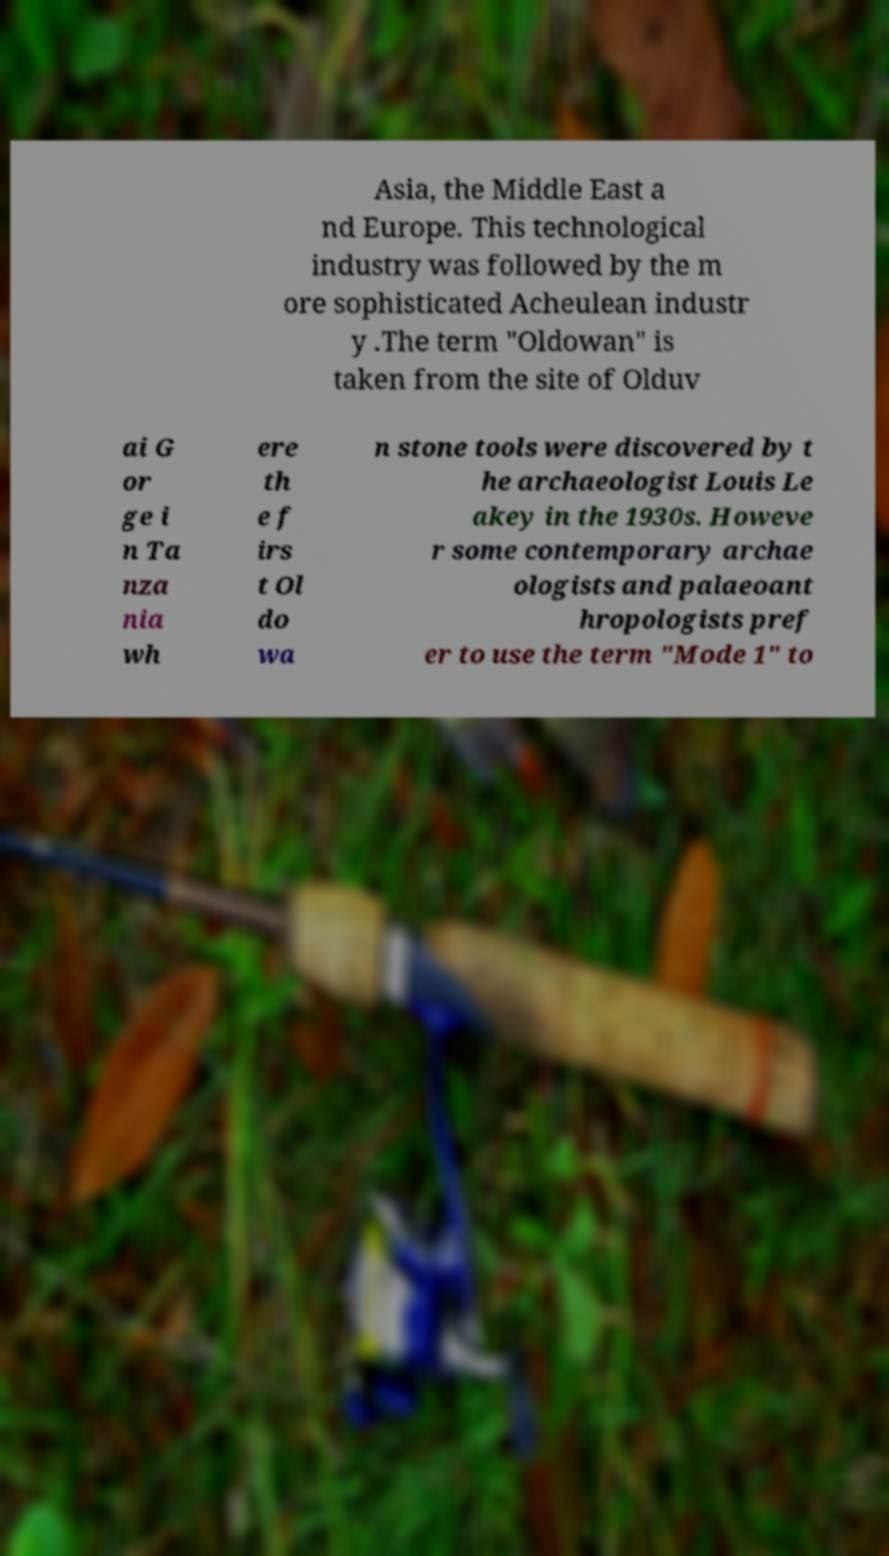Could you assist in decoding the text presented in this image and type it out clearly? Asia, the Middle East a nd Europe. This technological industry was followed by the m ore sophisticated Acheulean industr y .The term "Oldowan" is taken from the site of Olduv ai G or ge i n Ta nza nia wh ere th e f irs t Ol do wa n stone tools were discovered by t he archaeologist Louis Le akey in the 1930s. Howeve r some contemporary archae ologists and palaeoant hropologists pref er to use the term "Mode 1" to 